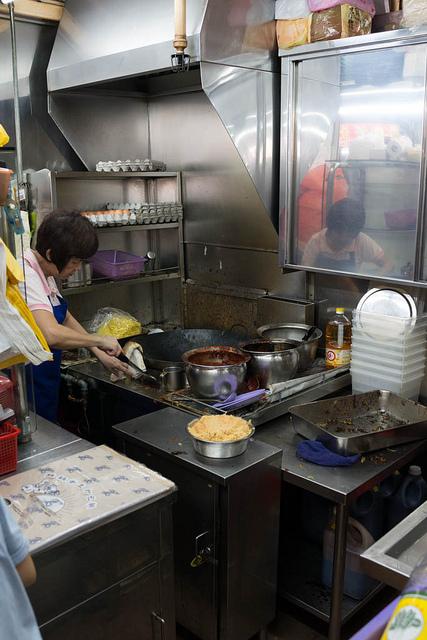Is this a crowded room?
Short answer required. No. Is this a typical home kitchen?
Give a very brief answer. No. Is she doing the dishes?
Be succinct. Yes. 